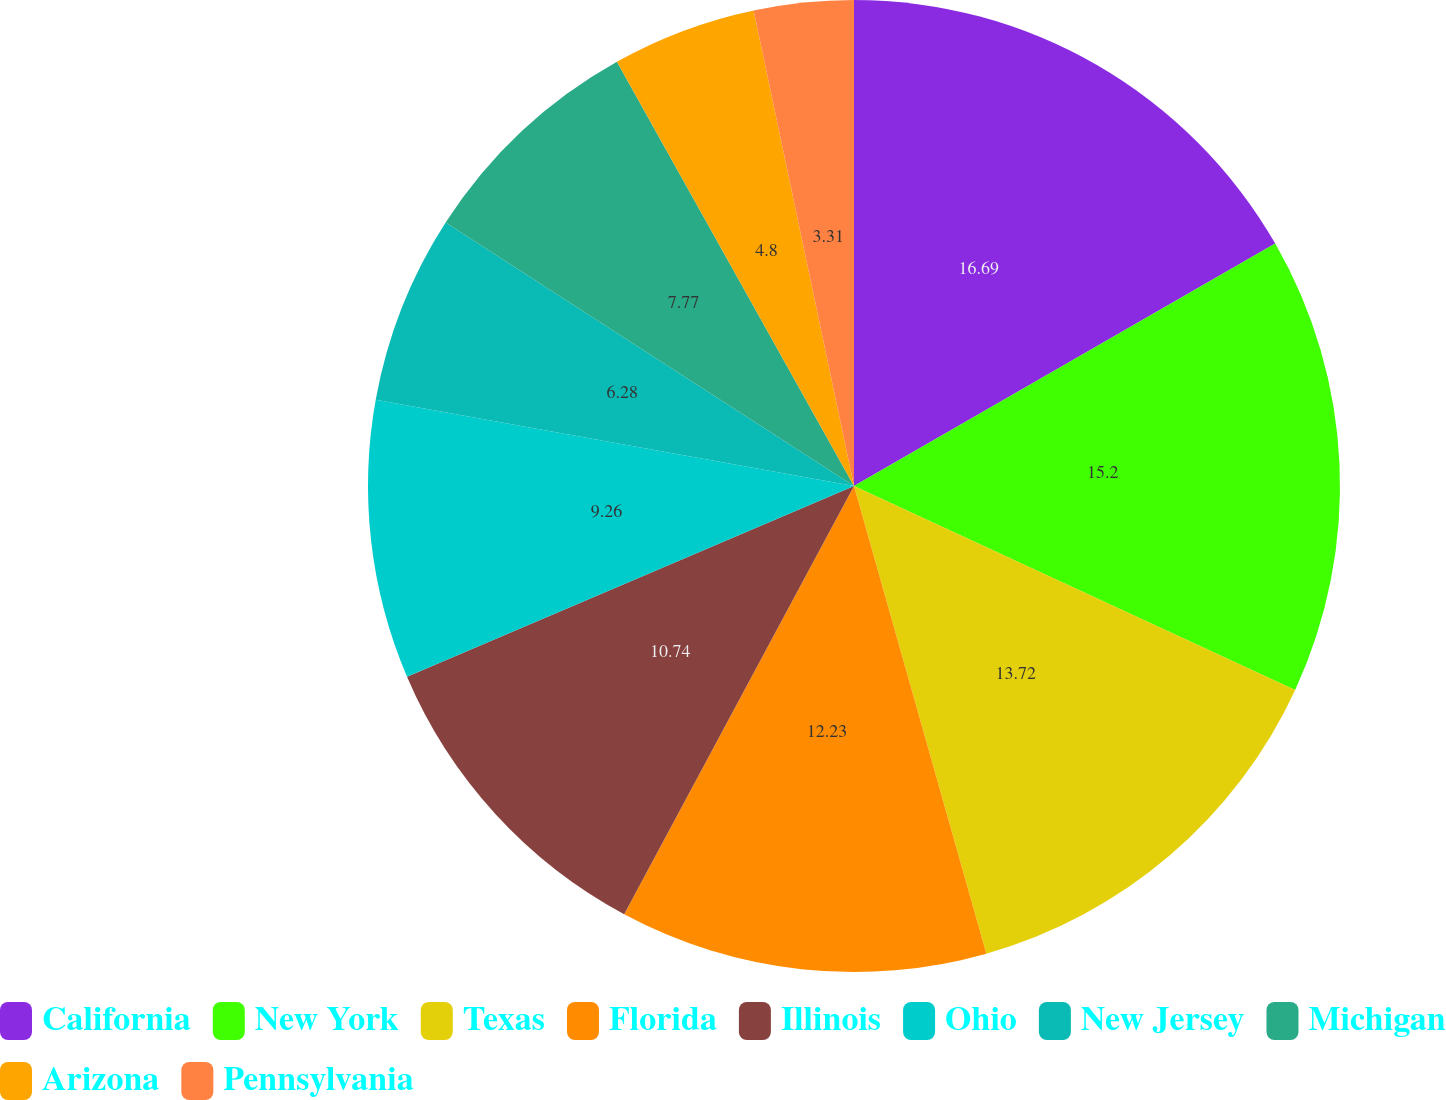<chart> <loc_0><loc_0><loc_500><loc_500><pie_chart><fcel>California<fcel>New York<fcel>Texas<fcel>Florida<fcel>Illinois<fcel>Ohio<fcel>New Jersey<fcel>Michigan<fcel>Arizona<fcel>Pennsylvania<nl><fcel>16.69%<fcel>15.2%<fcel>13.72%<fcel>12.23%<fcel>10.74%<fcel>9.26%<fcel>6.28%<fcel>7.77%<fcel>4.8%<fcel>3.31%<nl></chart> 